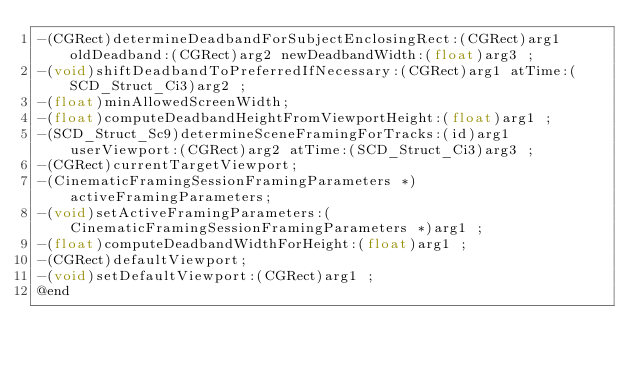<code> <loc_0><loc_0><loc_500><loc_500><_C_>-(CGRect)determineDeadbandForSubjectEnclosingRect:(CGRect)arg1 oldDeadband:(CGRect)arg2 newDeadbandWidth:(float)arg3 ;
-(void)shiftDeadbandToPreferredIfNecessary:(CGRect)arg1 atTime:(SCD_Struct_Ci3)arg2 ;
-(float)minAllowedScreenWidth;
-(float)computeDeadbandHeightFromViewportHeight:(float)arg1 ;
-(SCD_Struct_Sc9)determineSceneFramingForTracks:(id)arg1 userViewport:(CGRect)arg2 atTime:(SCD_Struct_Ci3)arg3 ;
-(CGRect)currentTargetViewport;
-(CinematicFramingSessionFramingParameters *)activeFramingParameters;
-(void)setActiveFramingParameters:(CinematicFramingSessionFramingParameters *)arg1 ;
-(float)computeDeadbandWidthForHeight:(float)arg1 ;
-(CGRect)defaultViewport;
-(void)setDefaultViewport:(CGRect)arg1 ;
@end

</code> 